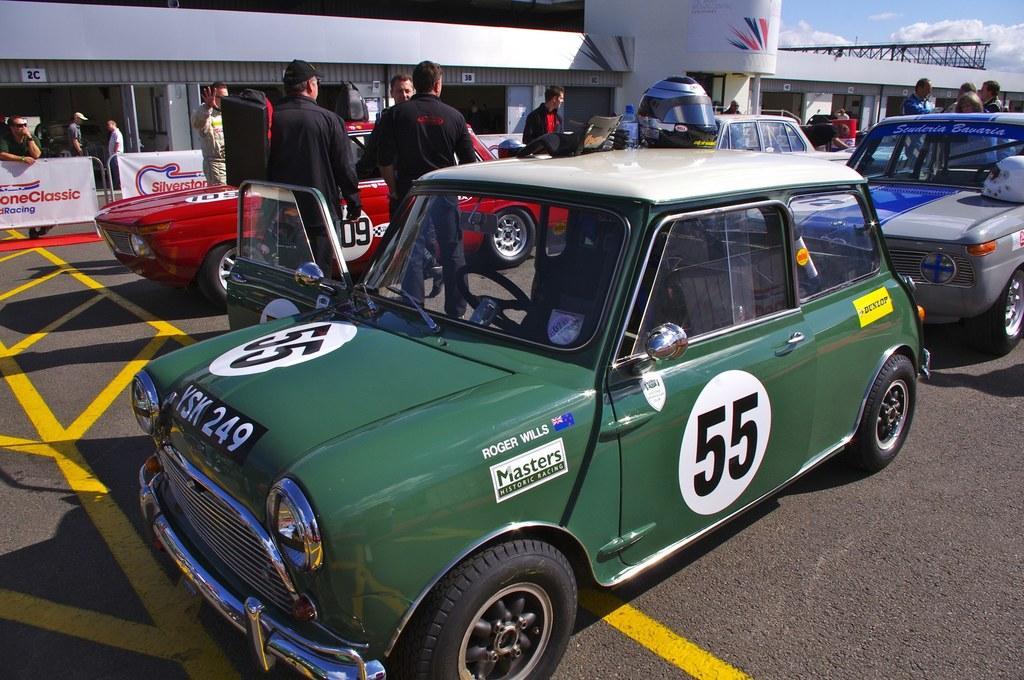In one or two sentences, can you explain what this image depicts? In the image we can see there are cars parked on the road and there are people standing beside the cars. Behind there is a building and there is a helmet kept on the car. 